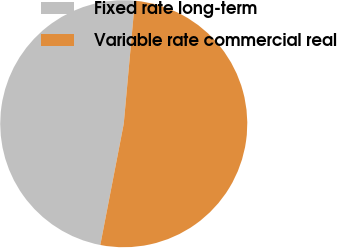<chart> <loc_0><loc_0><loc_500><loc_500><pie_chart><fcel>Fixed rate long-term<fcel>Variable rate commercial real<nl><fcel>48.4%<fcel>51.6%<nl></chart> 